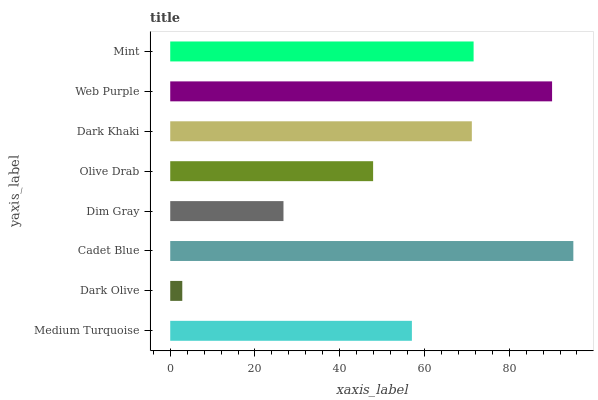Is Dark Olive the minimum?
Answer yes or no. Yes. Is Cadet Blue the maximum?
Answer yes or no. Yes. Is Cadet Blue the minimum?
Answer yes or no. No. Is Dark Olive the maximum?
Answer yes or no. No. Is Cadet Blue greater than Dark Olive?
Answer yes or no. Yes. Is Dark Olive less than Cadet Blue?
Answer yes or no. Yes. Is Dark Olive greater than Cadet Blue?
Answer yes or no. No. Is Cadet Blue less than Dark Olive?
Answer yes or no. No. Is Dark Khaki the high median?
Answer yes or no. Yes. Is Medium Turquoise the low median?
Answer yes or no. Yes. Is Cadet Blue the high median?
Answer yes or no. No. Is Dark Olive the low median?
Answer yes or no. No. 